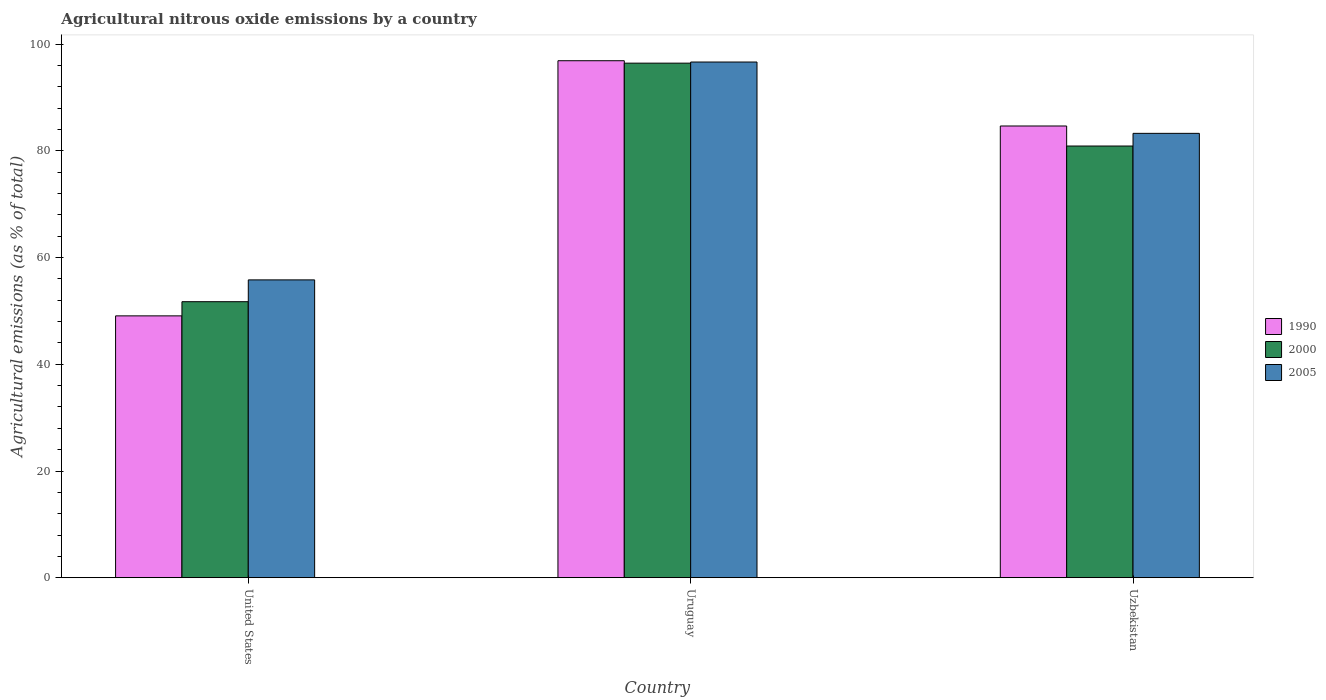How many different coloured bars are there?
Keep it short and to the point. 3. Are the number of bars per tick equal to the number of legend labels?
Provide a succinct answer. Yes. How many bars are there on the 1st tick from the left?
Keep it short and to the point. 3. How many bars are there on the 2nd tick from the right?
Your answer should be very brief. 3. What is the label of the 2nd group of bars from the left?
Give a very brief answer. Uruguay. What is the amount of agricultural nitrous oxide emitted in 1990 in United States?
Your response must be concise. 49.08. Across all countries, what is the maximum amount of agricultural nitrous oxide emitted in 1990?
Offer a terse response. 96.91. Across all countries, what is the minimum amount of agricultural nitrous oxide emitted in 1990?
Offer a very short reply. 49.08. In which country was the amount of agricultural nitrous oxide emitted in 1990 maximum?
Provide a succinct answer. Uruguay. In which country was the amount of agricultural nitrous oxide emitted in 1990 minimum?
Offer a terse response. United States. What is the total amount of agricultural nitrous oxide emitted in 2000 in the graph?
Your response must be concise. 229.11. What is the difference between the amount of agricultural nitrous oxide emitted in 2005 in Uruguay and that in Uzbekistan?
Offer a terse response. 13.37. What is the difference between the amount of agricultural nitrous oxide emitted in 2000 in United States and the amount of agricultural nitrous oxide emitted in 2005 in Uruguay?
Make the answer very short. -44.93. What is the average amount of agricultural nitrous oxide emitted in 2005 per country?
Offer a terse response. 78.59. What is the difference between the amount of agricultural nitrous oxide emitted of/in 1990 and amount of agricultural nitrous oxide emitted of/in 2000 in Uzbekistan?
Provide a short and direct response. 3.76. What is the ratio of the amount of agricultural nitrous oxide emitted in 2005 in United States to that in Uruguay?
Offer a very short reply. 0.58. Is the amount of agricultural nitrous oxide emitted in 2000 in United States less than that in Uzbekistan?
Ensure brevity in your answer.  Yes. What is the difference between the highest and the second highest amount of agricultural nitrous oxide emitted in 2000?
Give a very brief answer. 44.71. What is the difference between the highest and the lowest amount of agricultural nitrous oxide emitted in 1990?
Your response must be concise. 47.83. Is it the case that in every country, the sum of the amount of agricultural nitrous oxide emitted in 2000 and amount of agricultural nitrous oxide emitted in 2005 is greater than the amount of agricultural nitrous oxide emitted in 1990?
Offer a very short reply. Yes. How many bars are there?
Keep it short and to the point. 9. How many countries are there in the graph?
Offer a terse response. 3. Does the graph contain any zero values?
Your response must be concise. No. Where does the legend appear in the graph?
Keep it short and to the point. Center right. What is the title of the graph?
Your answer should be very brief. Agricultural nitrous oxide emissions by a country. Does "1975" appear as one of the legend labels in the graph?
Your answer should be very brief. No. What is the label or title of the Y-axis?
Provide a short and direct response. Agricultural emissions (as % of total). What is the Agricultural emissions (as % of total) of 1990 in United States?
Ensure brevity in your answer.  49.08. What is the Agricultural emissions (as % of total) in 2000 in United States?
Give a very brief answer. 51.74. What is the Agricultural emissions (as % of total) of 2005 in United States?
Keep it short and to the point. 55.83. What is the Agricultural emissions (as % of total) of 1990 in Uruguay?
Provide a succinct answer. 96.91. What is the Agricultural emissions (as % of total) in 2000 in Uruguay?
Provide a succinct answer. 96.45. What is the Agricultural emissions (as % of total) of 2005 in Uruguay?
Make the answer very short. 96.66. What is the Agricultural emissions (as % of total) of 1990 in Uzbekistan?
Offer a very short reply. 84.67. What is the Agricultural emissions (as % of total) of 2000 in Uzbekistan?
Provide a succinct answer. 80.92. What is the Agricultural emissions (as % of total) of 2005 in Uzbekistan?
Give a very brief answer. 83.29. Across all countries, what is the maximum Agricultural emissions (as % of total) of 1990?
Your response must be concise. 96.91. Across all countries, what is the maximum Agricultural emissions (as % of total) of 2000?
Provide a succinct answer. 96.45. Across all countries, what is the maximum Agricultural emissions (as % of total) in 2005?
Your response must be concise. 96.66. Across all countries, what is the minimum Agricultural emissions (as % of total) of 1990?
Your answer should be compact. 49.08. Across all countries, what is the minimum Agricultural emissions (as % of total) in 2000?
Your answer should be very brief. 51.74. Across all countries, what is the minimum Agricultural emissions (as % of total) of 2005?
Provide a short and direct response. 55.83. What is the total Agricultural emissions (as % of total) of 1990 in the graph?
Provide a succinct answer. 230.66. What is the total Agricultural emissions (as % of total) in 2000 in the graph?
Give a very brief answer. 229.11. What is the total Agricultural emissions (as % of total) of 2005 in the graph?
Offer a terse response. 235.78. What is the difference between the Agricultural emissions (as % of total) of 1990 in United States and that in Uruguay?
Your answer should be very brief. -47.83. What is the difference between the Agricultural emissions (as % of total) of 2000 in United States and that in Uruguay?
Give a very brief answer. -44.71. What is the difference between the Agricultural emissions (as % of total) in 2005 in United States and that in Uruguay?
Provide a short and direct response. -40.84. What is the difference between the Agricultural emissions (as % of total) of 1990 in United States and that in Uzbekistan?
Provide a succinct answer. -35.59. What is the difference between the Agricultural emissions (as % of total) of 2000 in United States and that in Uzbekistan?
Your answer should be very brief. -29.18. What is the difference between the Agricultural emissions (as % of total) in 2005 in United States and that in Uzbekistan?
Keep it short and to the point. -27.47. What is the difference between the Agricultural emissions (as % of total) in 1990 in Uruguay and that in Uzbekistan?
Offer a terse response. 12.23. What is the difference between the Agricultural emissions (as % of total) in 2000 in Uruguay and that in Uzbekistan?
Your answer should be compact. 15.53. What is the difference between the Agricultural emissions (as % of total) in 2005 in Uruguay and that in Uzbekistan?
Offer a terse response. 13.37. What is the difference between the Agricultural emissions (as % of total) of 1990 in United States and the Agricultural emissions (as % of total) of 2000 in Uruguay?
Offer a very short reply. -47.37. What is the difference between the Agricultural emissions (as % of total) of 1990 in United States and the Agricultural emissions (as % of total) of 2005 in Uruguay?
Offer a very short reply. -47.58. What is the difference between the Agricultural emissions (as % of total) in 2000 in United States and the Agricultural emissions (as % of total) in 2005 in Uruguay?
Your answer should be very brief. -44.93. What is the difference between the Agricultural emissions (as % of total) in 1990 in United States and the Agricultural emissions (as % of total) in 2000 in Uzbekistan?
Your answer should be very brief. -31.84. What is the difference between the Agricultural emissions (as % of total) in 1990 in United States and the Agricultural emissions (as % of total) in 2005 in Uzbekistan?
Your answer should be very brief. -34.21. What is the difference between the Agricultural emissions (as % of total) in 2000 in United States and the Agricultural emissions (as % of total) in 2005 in Uzbekistan?
Your answer should be very brief. -31.56. What is the difference between the Agricultural emissions (as % of total) of 1990 in Uruguay and the Agricultural emissions (as % of total) of 2000 in Uzbekistan?
Give a very brief answer. 15.99. What is the difference between the Agricultural emissions (as % of total) of 1990 in Uruguay and the Agricultural emissions (as % of total) of 2005 in Uzbekistan?
Ensure brevity in your answer.  13.61. What is the difference between the Agricultural emissions (as % of total) of 2000 in Uruguay and the Agricultural emissions (as % of total) of 2005 in Uzbekistan?
Make the answer very short. 13.16. What is the average Agricultural emissions (as % of total) of 1990 per country?
Your answer should be compact. 76.89. What is the average Agricultural emissions (as % of total) of 2000 per country?
Offer a very short reply. 76.37. What is the average Agricultural emissions (as % of total) of 2005 per country?
Your answer should be compact. 78.59. What is the difference between the Agricultural emissions (as % of total) in 1990 and Agricultural emissions (as % of total) in 2000 in United States?
Your answer should be compact. -2.66. What is the difference between the Agricultural emissions (as % of total) of 1990 and Agricultural emissions (as % of total) of 2005 in United States?
Provide a succinct answer. -6.75. What is the difference between the Agricultural emissions (as % of total) of 2000 and Agricultural emissions (as % of total) of 2005 in United States?
Make the answer very short. -4.09. What is the difference between the Agricultural emissions (as % of total) in 1990 and Agricultural emissions (as % of total) in 2000 in Uruguay?
Offer a terse response. 0.46. What is the difference between the Agricultural emissions (as % of total) in 1990 and Agricultural emissions (as % of total) in 2005 in Uruguay?
Offer a very short reply. 0.24. What is the difference between the Agricultural emissions (as % of total) of 2000 and Agricultural emissions (as % of total) of 2005 in Uruguay?
Your response must be concise. -0.21. What is the difference between the Agricultural emissions (as % of total) of 1990 and Agricultural emissions (as % of total) of 2000 in Uzbekistan?
Offer a very short reply. 3.76. What is the difference between the Agricultural emissions (as % of total) of 1990 and Agricultural emissions (as % of total) of 2005 in Uzbekistan?
Your answer should be very brief. 1.38. What is the difference between the Agricultural emissions (as % of total) in 2000 and Agricultural emissions (as % of total) in 2005 in Uzbekistan?
Ensure brevity in your answer.  -2.38. What is the ratio of the Agricultural emissions (as % of total) in 1990 in United States to that in Uruguay?
Your answer should be very brief. 0.51. What is the ratio of the Agricultural emissions (as % of total) in 2000 in United States to that in Uruguay?
Your response must be concise. 0.54. What is the ratio of the Agricultural emissions (as % of total) in 2005 in United States to that in Uruguay?
Ensure brevity in your answer.  0.58. What is the ratio of the Agricultural emissions (as % of total) of 1990 in United States to that in Uzbekistan?
Your answer should be compact. 0.58. What is the ratio of the Agricultural emissions (as % of total) of 2000 in United States to that in Uzbekistan?
Provide a succinct answer. 0.64. What is the ratio of the Agricultural emissions (as % of total) in 2005 in United States to that in Uzbekistan?
Offer a terse response. 0.67. What is the ratio of the Agricultural emissions (as % of total) of 1990 in Uruguay to that in Uzbekistan?
Your response must be concise. 1.14. What is the ratio of the Agricultural emissions (as % of total) in 2000 in Uruguay to that in Uzbekistan?
Ensure brevity in your answer.  1.19. What is the ratio of the Agricultural emissions (as % of total) of 2005 in Uruguay to that in Uzbekistan?
Provide a succinct answer. 1.16. What is the difference between the highest and the second highest Agricultural emissions (as % of total) in 1990?
Keep it short and to the point. 12.23. What is the difference between the highest and the second highest Agricultural emissions (as % of total) in 2000?
Your answer should be compact. 15.53. What is the difference between the highest and the second highest Agricultural emissions (as % of total) of 2005?
Give a very brief answer. 13.37. What is the difference between the highest and the lowest Agricultural emissions (as % of total) in 1990?
Provide a succinct answer. 47.83. What is the difference between the highest and the lowest Agricultural emissions (as % of total) of 2000?
Give a very brief answer. 44.71. What is the difference between the highest and the lowest Agricultural emissions (as % of total) in 2005?
Offer a terse response. 40.84. 